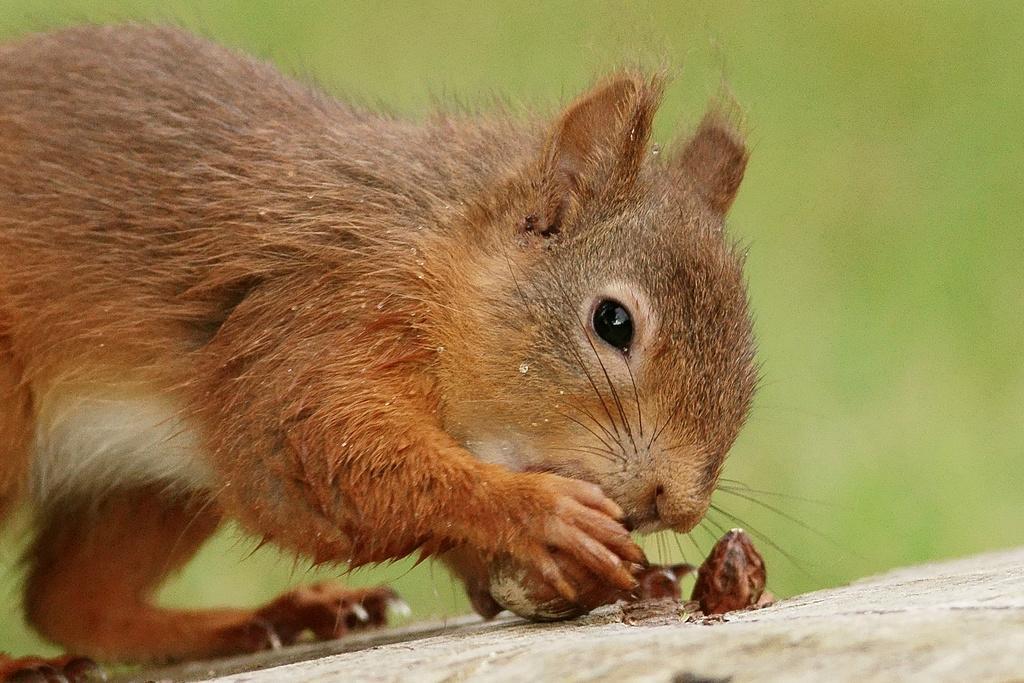Describe this image in one or two sentences. In this image we can see a squirrel holding something in the hand. In the background it is blur. 